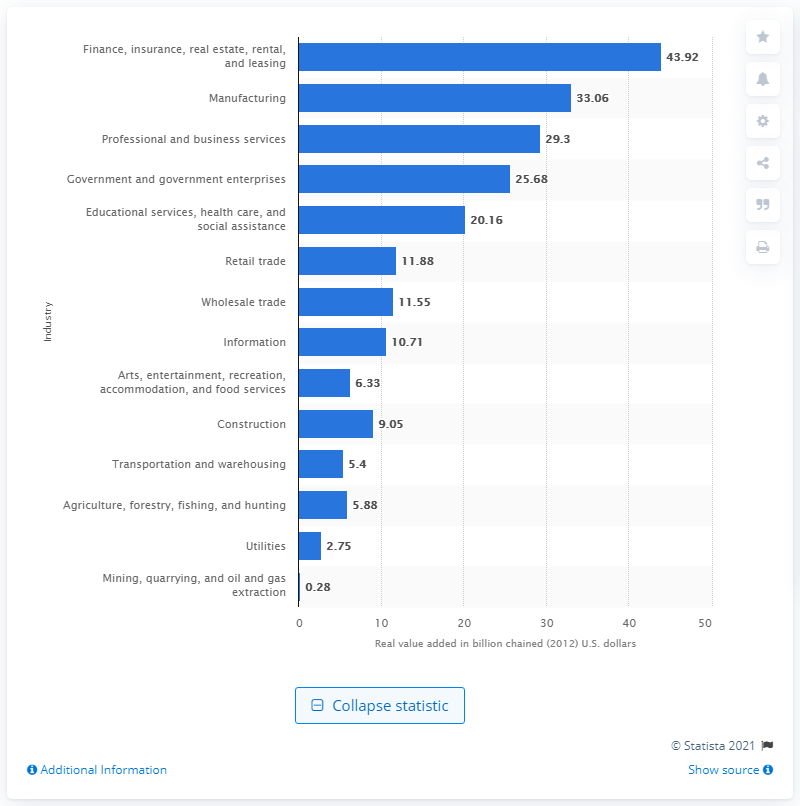List a handful of essential elements in this visual. In 2012, the finance, insurance, real estate, rental, and leasing industry contributed 43.92 dollars to the Gross Domestic Product (GDP) of Oregon. 